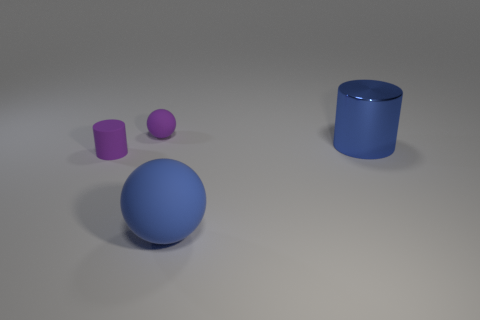What is the material of the thing that is the same color as the big matte ball?
Provide a succinct answer. Metal. What material is the blue thing behind the purple thing in front of the tiny ball?
Give a very brief answer. Metal. Are there more red balls than small cylinders?
Your response must be concise. No. Is the color of the small rubber cylinder the same as the tiny ball?
Your answer should be very brief. Yes. There is a purple thing that is the same size as the purple rubber ball; what material is it?
Keep it short and to the point. Rubber. Do the small purple sphere and the blue ball have the same material?
Your response must be concise. Yes. What number of big spheres are the same material as the small cylinder?
Give a very brief answer. 1. What number of objects are either tiny objects that are in front of the large metallic thing or objects left of the large blue shiny thing?
Make the answer very short. 3. Is the number of blue objects in front of the small cylinder greater than the number of big rubber balls on the right side of the large shiny object?
Offer a terse response. Yes. What color is the tiny matte thing that is behind the shiny object?
Your response must be concise. Purple. 